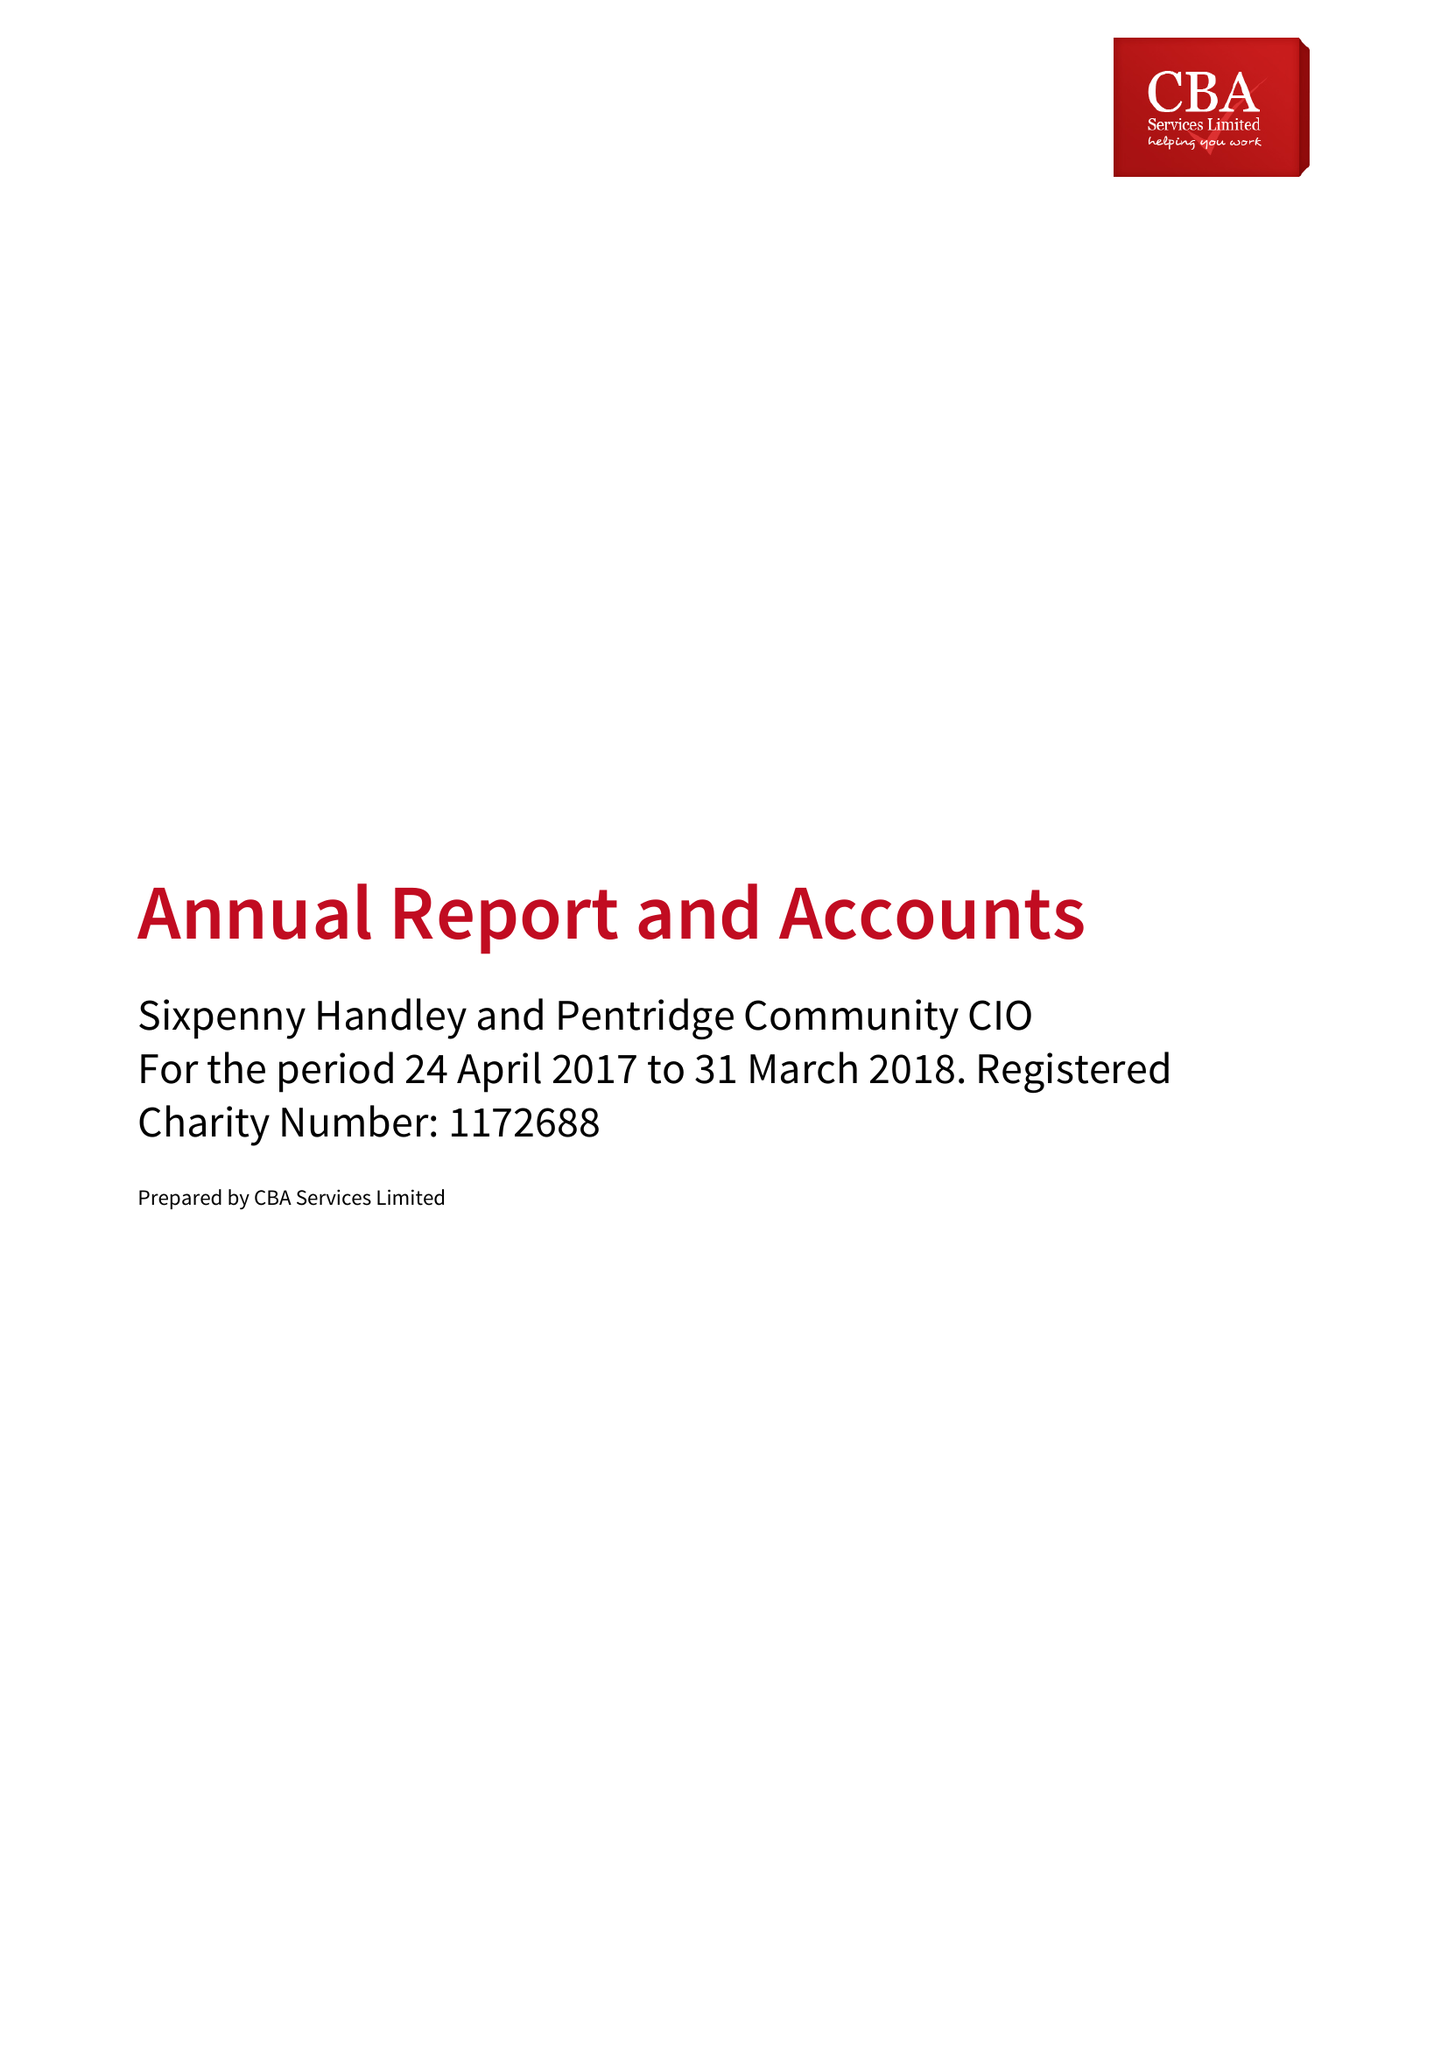What is the value for the address__postcode?
Answer the question using a single word or phrase. SP5 5PA 